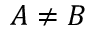Convert formula to latex. <formula><loc_0><loc_0><loc_500><loc_500>A \ne B</formula> 